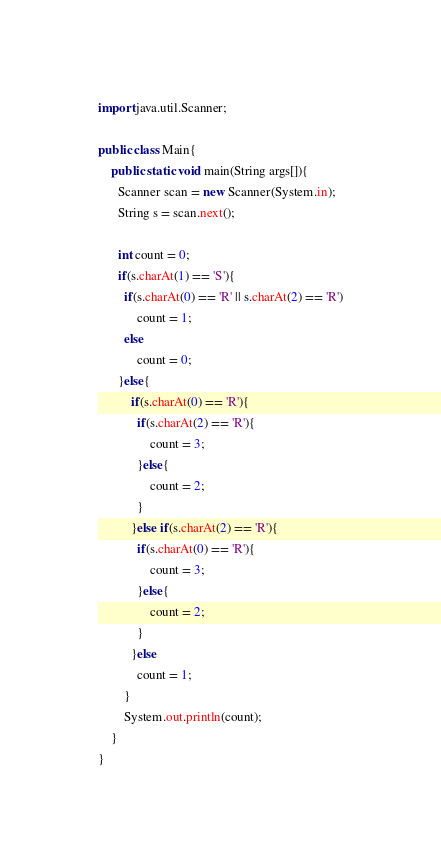Convert code to text. <code><loc_0><loc_0><loc_500><loc_500><_Java_>import java.util.Scanner;

public class Main{
	public static void main(String args[]){
      Scanner scan = new Scanner(System.in);
      String s = scan.next();

      int count = 0;
      if(s.charAt(1) == 'S'){
        if(s.charAt(0) == 'R' || s.charAt(2) == 'R')
            count = 1;
        else
            count = 0;
      }else{
          if(s.charAt(0) == 'R'){
            if(s.charAt(2) == 'R'){
                count = 3;
            }else{
                count = 2;
            }
          }else if(s.charAt(2) == 'R'){
            if(s.charAt(0) == 'R'){
                count = 3;
            }else{
                count = 2;
            }
          }else
            count = 1;
        }
        System.out.println(count);
    }
}</code> 